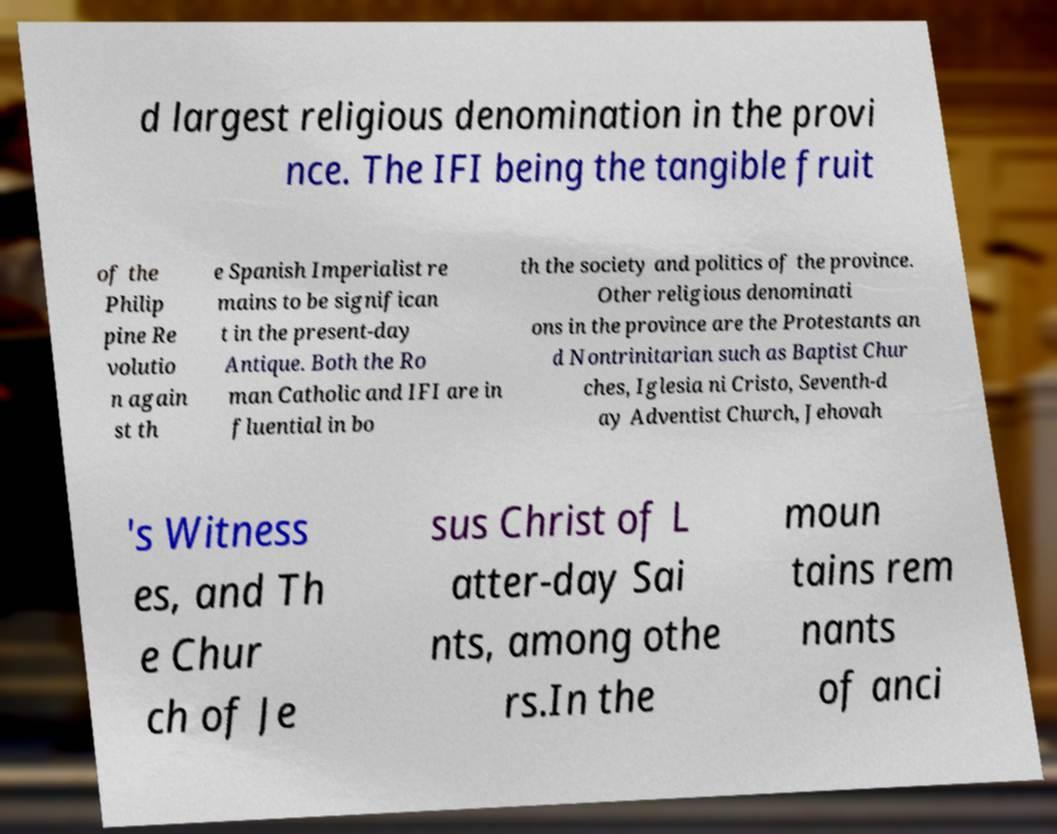Could you assist in decoding the text presented in this image and type it out clearly? d largest religious denomination in the provi nce. The IFI being the tangible fruit of the Philip pine Re volutio n again st th e Spanish Imperialist re mains to be significan t in the present-day Antique. Both the Ro man Catholic and IFI are in fluential in bo th the society and politics of the province. Other religious denominati ons in the province are the Protestants an d Nontrinitarian such as Baptist Chur ches, Iglesia ni Cristo, Seventh-d ay Adventist Church, Jehovah 's Witness es, and Th e Chur ch of Je sus Christ of L atter-day Sai nts, among othe rs.In the moun tains rem nants of anci 